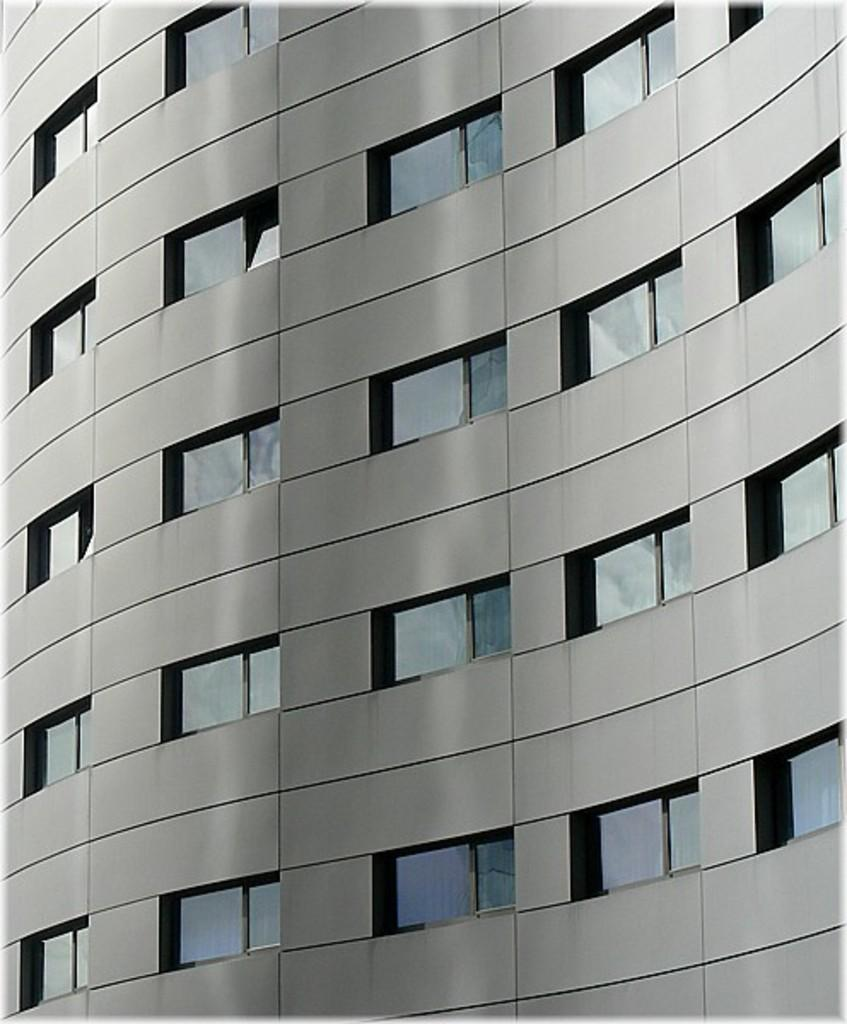What is the main structure in the image? There is a building in the image. What feature can be seen on the building? The building has windows. What type of popcorn is being served in the building's cafeteria in the image? There is no information about a cafeteria or popcorn in the image; it only shows a building with windows. 